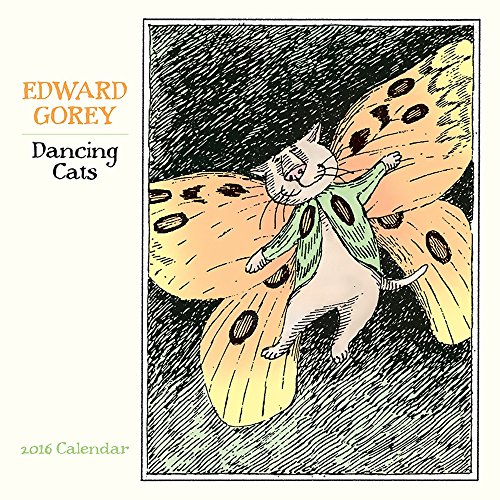Is this book related to Calendars? Yes, this book categorically falls under calendars, being a collection of months and dates accompanied by visually engaging illustrations for the year 2016. 